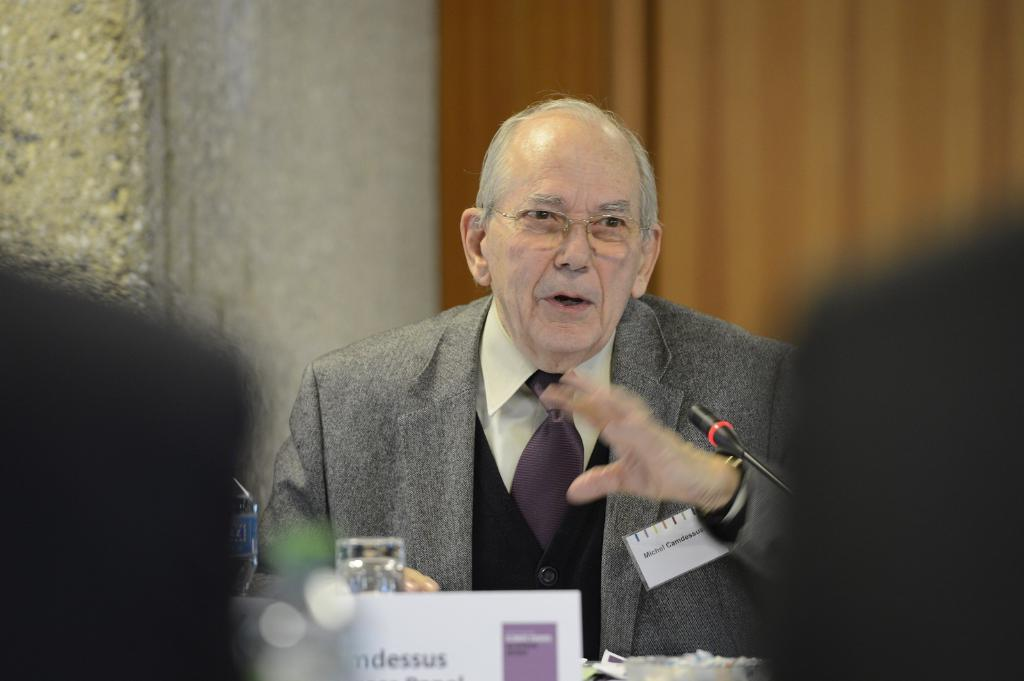<image>
Summarize the visual content of the image. An older man with the name tag Michael Gamdessus is speaking. 